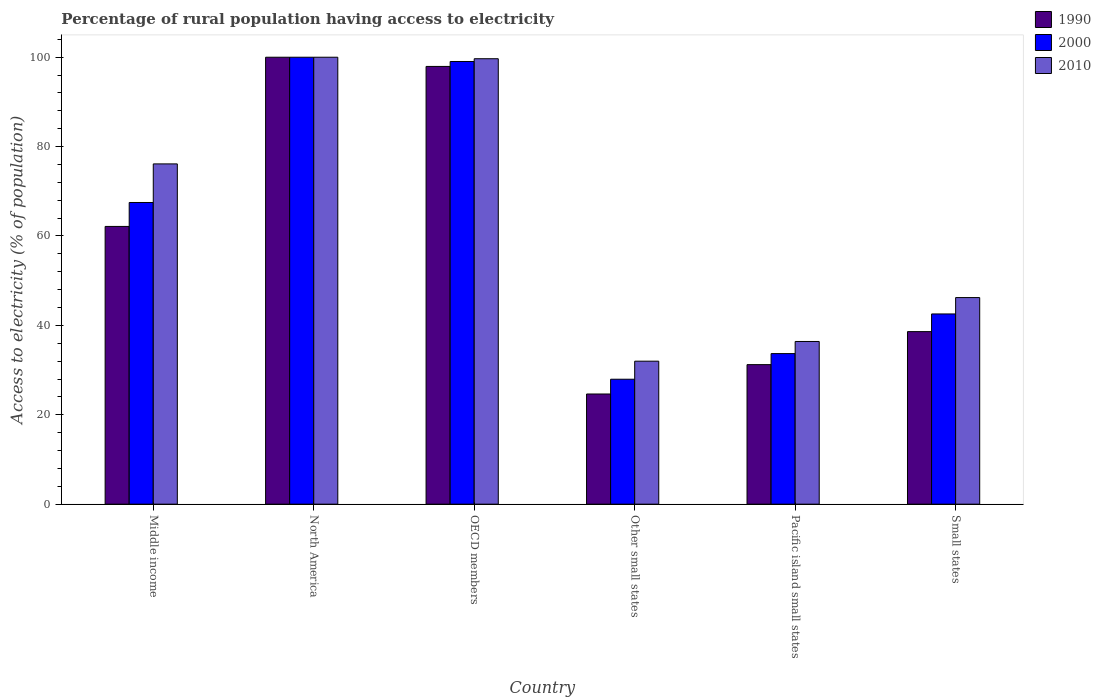How many groups of bars are there?
Offer a terse response. 6. Are the number of bars per tick equal to the number of legend labels?
Give a very brief answer. Yes. How many bars are there on the 4th tick from the left?
Your response must be concise. 3. How many bars are there on the 6th tick from the right?
Your response must be concise. 3. What is the percentage of rural population having access to electricity in 2010 in Pacific island small states?
Your answer should be compact. 36.4. Across all countries, what is the minimum percentage of rural population having access to electricity in 1990?
Give a very brief answer. 24.65. In which country was the percentage of rural population having access to electricity in 2010 minimum?
Give a very brief answer. Other small states. What is the total percentage of rural population having access to electricity in 2000 in the graph?
Give a very brief answer. 370.74. What is the difference between the percentage of rural population having access to electricity in 2010 in Middle income and that in North America?
Provide a succinct answer. -23.87. What is the difference between the percentage of rural population having access to electricity in 2000 in Middle income and the percentage of rural population having access to electricity in 2010 in OECD members?
Give a very brief answer. -32.17. What is the average percentage of rural population having access to electricity in 2000 per country?
Your response must be concise. 61.79. What is the difference between the percentage of rural population having access to electricity of/in 1990 and percentage of rural population having access to electricity of/in 2010 in Small states?
Offer a terse response. -7.62. What is the ratio of the percentage of rural population having access to electricity in 1990 in Other small states to that in Pacific island small states?
Provide a succinct answer. 0.79. What is the difference between the highest and the second highest percentage of rural population having access to electricity in 2000?
Your response must be concise. -31.55. What is the difference between the highest and the lowest percentage of rural population having access to electricity in 2000?
Give a very brief answer. 72.04. In how many countries, is the percentage of rural population having access to electricity in 2010 greater than the average percentage of rural population having access to electricity in 2010 taken over all countries?
Your answer should be compact. 3. What does the 1st bar from the left in OECD members represents?
Make the answer very short. 1990. How many bars are there?
Offer a very short reply. 18. Are the values on the major ticks of Y-axis written in scientific E-notation?
Your response must be concise. No. Where does the legend appear in the graph?
Offer a very short reply. Top right. How many legend labels are there?
Offer a terse response. 3. How are the legend labels stacked?
Offer a terse response. Vertical. What is the title of the graph?
Ensure brevity in your answer.  Percentage of rural population having access to electricity. What is the label or title of the Y-axis?
Make the answer very short. Access to electricity (% of population). What is the Access to electricity (% of population) in 1990 in Middle income?
Your answer should be compact. 62.14. What is the Access to electricity (% of population) of 2000 in Middle income?
Offer a terse response. 67.5. What is the Access to electricity (% of population) in 2010 in Middle income?
Your answer should be compact. 76.13. What is the Access to electricity (% of population) in 1990 in North America?
Provide a short and direct response. 100. What is the Access to electricity (% of population) of 2000 in North America?
Offer a very short reply. 100. What is the Access to electricity (% of population) of 2010 in North America?
Your answer should be compact. 100. What is the Access to electricity (% of population) in 1990 in OECD members?
Your answer should be very brief. 97.94. What is the Access to electricity (% of population) of 2000 in OECD members?
Keep it short and to the point. 99.04. What is the Access to electricity (% of population) of 2010 in OECD members?
Offer a terse response. 99.66. What is the Access to electricity (% of population) in 1990 in Other small states?
Provide a succinct answer. 24.65. What is the Access to electricity (% of population) in 2000 in Other small states?
Ensure brevity in your answer.  27.96. What is the Access to electricity (% of population) of 2010 in Other small states?
Give a very brief answer. 31.99. What is the Access to electricity (% of population) of 1990 in Pacific island small states?
Your answer should be compact. 31.22. What is the Access to electricity (% of population) in 2000 in Pacific island small states?
Give a very brief answer. 33.69. What is the Access to electricity (% of population) in 2010 in Pacific island small states?
Your response must be concise. 36.4. What is the Access to electricity (% of population) in 1990 in Small states?
Ensure brevity in your answer.  38.61. What is the Access to electricity (% of population) in 2000 in Small states?
Offer a terse response. 42.56. What is the Access to electricity (% of population) in 2010 in Small states?
Your response must be concise. 46.22. Across all countries, what is the maximum Access to electricity (% of population) in 2010?
Offer a terse response. 100. Across all countries, what is the minimum Access to electricity (% of population) of 1990?
Make the answer very short. 24.65. Across all countries, what is the minimum Access to electricity (% of population) in 2000?
Provide a short and direct response. 27.96. Across all countries, what is the minimum Access to electricity (% of population) in 2010?
Keep it short and to the point. 31.99. What is the total Access to electricity (% of population) in 1990 in the graph?
Make the answer very short. 354.56. What is the total Access to electricity (% of population) of 2000 in the graph?
Offer a terse response. 370.74. What is the total Access to electricity (% of population) in 2010 in the graph?
Make the answer very short. 390.41. What is the difference between the Access to electricity (% of population) in 1990 in Middle income and that in North America?
Provide a short and direct response. -37.86. What is the difference between the Access to electricity (% of population) in 2000 in Middle income and that in North America?
Your answer should be compact. -32.5. What is the difference between the Access to electricity (% of population) of 2010 in Middle income and that in North America?
Give a very brief answer. -23.87. What is the difference between the Access to electricity (% of population) in 1990 in Middle income and that in OECD members?
Provide a short and direct response. -35.8. What is the difference between the Access to electricity (% of population) of 2000 in Middle income and that in OECD members?
Your response must be concise. -31.55. What is the difference between the Access to electricity (% of population) in 2010 in Middle income and that in OECD members?
Your answer should be compact. -23.53. What is the difference between the Access to electricity (% of population) in 1990 in Middle income and that in Other small states?
Your answer should be compact. 37.49. What is the difference between the Access to electricity (% of population) of 2000 in Middle income and that in Other small states?
Provide a succinct answer. 39.54. What is the difference between the Access to electricity (% of population) of 2010 in Middle income and that in Other small states?
Make the answer very short. 44.14. What is the difference between the Access to electricity (% of population) of 1990 in Middle income and that in Pacific island small states?
Give a very brief answer. 30.92. What is the difference between the Access to electricity (% of population) in 2000 in Middle income and that in Pacific island small states?
Your answer should be compact. 33.81. What is the difference between the Access to electricity (% of population) in 2010 in Middle income and that in Pacific island small states?
Offer a very short reply. 39.73. What is the difference between the Access to electricity (% of population) of 1990 in Middle income and that in Small states?
Your answer should be very brief. 23.53. What is the difference between the Access to electricity (% of population) in 2000 in Middle income and that in Small states?
Provide a short and direct response. 24.94. What is the difference between the Access to electricity (% of population) of 2010 in Middle income and that in Small states?
Provide a succinct answer. 29.91. What is the difference between the Access to electricity (% of population) of 1990 in North America and that in OECD members?
Offer a very short reply. 2.06. What is the difference between the Access to electricity (% of population) of 2000 in North America and that in OECD members?
Make the answer very short. 0.96. What is the difference between the Access to electricity (% of population) of 2010 in North America and that in OECD members?
Make the answer very short. 0.34. What is the difference between the Access to electricity (% of population) in 1990 in North America and that in Other small states?
Your answer should be compact. 75.35. What is the difference between the Access to electricity (% of population) of 2000 in North America and that in Other small states?
Provide a succinct answer. 72.04. What is the difference between the Access to electricity (% of population) of 2010 in North America and that in Other small states?
Make the answer very short. 68.01. What is the difference between the Access to electricity (% of population) of 1990 in North America and that in Pacific island small states?
Offer a terse response. 68.78. What is the difference between the Access to electricity (% of population) of 2000 in North America and that in Pacific island small states?
Provide a succinct answer. 66.31. What is the difference between the Access to electricity (% of population) of 2010 in North America and that in Pacific island small states?
Provide a succinct answer. 63.6. What is the difference between the Access to electricity (% of population) of 1990 in North America and that in Small states?
Make the answer very short. 61.39. What is the difference between the Access to electricity (% of population) of 2000 in North America and that in Small states?
Provide a succinct answer. 57.44. What is the difference between the Access to electricity (% of population) of 2010 in North America and that in Small states?
Offer a very short reply. 53.78. What is the difference between the Access to electricity (% of population) in 1990 in OECD members and that in Other small states?
Provide a succinct answer. 73.29. What is the difference between the Access to electricity (% of population) in 2000 in OECD members and that in Other small states?
Your answer should be compact. 71.09. What is the difference between the Access to electricity (% of population) of 2010 in OECD members and that in Other small states?
Offer a terse response. 67.67. What is the difference between the Access to electricity (% of population) in 1990 in OECD members and that in Pacific island small states?
Provide a short and direct response. 66.72. What is the difference between the Access to electricity (% of population) in 2000 in OECD members and that in Pacific island small states?
Ensure brevity in your answer.  65.36. What is the difference between the Access to electricity (% of population) in 2010 in OECD members and that in Pacific island small states?
Offer a very short reply. 63.26. What is the difference between the Access to electricity (% of population) in 1990 in OECD members and that in Small states?
Keep it short and to the point. 59.33. What is the difference between the Access to electricity (% of population) of 2000 in OECD members and that in Small states?
Your response must be concise. 56.48. What is the difference between the Access to electricity (% of population) of 2010 in OECD members and that in Small states?
Provide a short and direct response. 53.44. What is the difference between the Access to electricity (% of population) in 1990 in Other small states and that in Pacific island small states?
Your answer should be compact. -6.57. What is the difference between the Access to electricity (% of population) of 2000 in Other small states and that in Pacific island small states?
Offer a terse response. -5.73. What is the difference between the Access to electricity (% of population) in 2010 in Other small states and that in Pacific island small states?
Provide a succinct answer. -4.41. What is the difference between the Access to electricity (% of population) in 1990 in Other small states and that in Small states?
Your answer should be compact. -13.96. What is the difference between the Access to electricity (% of population) of 2000 in Other small states and that in Small states?
Give a very brief answer. -14.61. What is the difference between the Access to electricity (% of population) of 2010 in Other small states and that in Small states?
Your answer should be compact. -14.23. What is the difference between the Access to electricity (% of population) of 1990 in Pacific island small states and that in Small states?
Your answer should be compact. -7.39. What is the difference between the Access to electricity (% of population) of 2000 in Pacific island small states and that in Small states?
Your response must be concise. -8.87. What is the difference between the Access to electricity (% of population) in 2010 in Pacific island small states and that in Small states?
Ensure brevity in your answer.  -9.82. What is the difference between the Access to electricity (% of population) of 1990 in Middle income and the Access to electricity (% of population) of 2000 in North America?
Provide a succinct answer. -37.86. What is the difference between the Access to electricity (% of population) in 1990 in Middle income and the Access to electricity (% of population) in 2010 in North America?
Your response must be concise. -37.86. What is the difference between the Access to electricity (% of population) of 2000 in Middle income and the Access to electricity (% of population) of 2010 in North America?
Make the answer very short. -32.5. What is the difference between the Access to electricity (% of population) of 1990 in Middle income and the Access to electricity (% of population) of 2000 in OECD members?
Provide a short and direct response. -36.9. What is the difference between the Access to electricity (% of population) in 1990 in Middle income and the Access to electricity (% of population) in 2010 in OECD members?
Your answer should be very brief. -37.52. What is the difference between the Access to electricity (% of population) in 2000 in Middle income and the Access to electricity (% of population) in 2010 in OECD members?
Your answer should be very brief. -32.17. What is the difference between the Access to electricity (% of population) in 1990 in Middle income and the Access to electricity (% of population) in 2000 in Other small states?
Provide a short and direct response. 34.19. What is the difference between the Access to electricity (% of population) in 1990 in Middle income and the Access to electricity (% of population) in 2010 in Other small states?
Offer a very short reply. 30.15. What is the difference between the Access to electricity (% of population) in 2000 in Middle income and the Access to electricity (% of population) in 2010 in Other small states?
Your answer should be very brief. 35.51. What is the difference between the Access to electricity (% of population) in 1990 in Middle income and the Access to electricity (% of population) in 2000 in Pacific island small states?
Keep it short and to the point. 28.45. What is the difference between the Access to electricity (% of population) in 1990 in Middle income and the Access to electricity (% of population) in 2010 in Pacific island small states?
Your response must be concise. 25.74. What is the difference between the Access to electricity (% of population) of 2000 in Middle income and the Access to electricity (% of population) of 2010 in Pacific island small states?
Offer a very short reply. 31.1. What is the difference between the Access to electricity (% of population) of 1990 in Middle income and the Access to electricity (% of population) of 2000 in Small states?
Ensure brevity in your answer.  19.58. What is the difference between the Access to electricity (% of population) of 1990 in Middle income and the Access to electricity (% of population) of 2010 in Small states?
Offer a very short reply. 15.92. What is the difference between the Access to electricity (% of population) in 2000 in Middle income and the Access to electricity (% of population) in 2010 in Small states?
Your answer should be compact. 21.27. What is the difference between the Access to electricity (% of population) in 1990 in North America and the Access to electricity (% of population) in 2000 in OECD members?
Your answer should be compact. 0.96. What is the difference between the Access to electricity (% of population) in 1990 in North America and the Access to electricity (% of population) in 2010 in OECD members?
Keep it short and to the point. 0.34. What is the difference between the Access to electricity (% of population) in 2000 in North America and the Access to electricity (% of population) in 2010 in OECD members?
Your response must be concise. 0.34. What is the difference between the Access to electricity (% of population) of 1990 in North America and the Access to electricity (% of population) of 2000 in Other small states?
Provide a succinct answer. 72.04. What is the difference between the Access to electricity (% of population) in 1990 in North America and the Access to electricity (% of population) in 2010 in Other small states?
Ensure brevity in your answer.  68.01. What is the difference between the Access to electricity (% of population) in 2000 in North America and the Access to electricity (% of population) in 2010 in Other small states?
Keep it short and to the point. 68.01. What is the difference between the Access to electricity (% of population) of 1990 in North America and the Access to electricity (% of population) of 2000 in Pacific island small states?
Your response must be concise. 66.31. What is the difference between the Access to electricity (% of population) of 1990 in North America and the Access to electricity (% of population) of 2010 in Pacific island small states?
Offer a terse response. 63.6. What is the difference between the Access to electricity (% of population) in 2000 in North America and the Access to electricity (% of population) in 2010 in Pacific island small states?
Your answer should be very brief. 63.6. What is the difference between the Access to electricity (% of population) in 1990 in North America and the Access to electricity (% of population) in 2000 in Small states?
Make the answer very short. 57.44. What is the difference between the Access to electricity (% of population) in 1990 in North America and the Access to electricity (% of population) in 2010 in Small states?
Keep it short and to the point. 53.78. What is the difference between the Access to electricity (% of population) of 2000 in North America and the Access to electricity (% of population) of 2010 in Small states?
Provide a short and direct response. 53.78. What is the difference between the Access to electricity (% of population) of 1990 in OECD members and the Access to electricity (% of population) of 2000 in Other small states?
Keep it short and to the point. 69.98. What is the difference between the Access to electricity (% of population) in 1990 in OECD members and the Access to electricity (% of population) in 2010 in Other small states?
Provide a short and direct response. 65.95. What is the difference between the Access to electricity (% of population) in 2000 in OECD members and the Access to electricity (% of population) in 2010 in Other small states?
Provide a succinct answer. 67.05. What is the difference between the Access to electricity (% of population) of 1990 in OECD members and the Access to electricity (% of population) of 2000 in Pacific island small states?
Provide a succinct answer. 64.25. What is the difference between the Access to electricity (% of population) in 1990 in OECD members and the Access to electricity (% of population) in 2010 in Pacific island small states?
Your answer should be very brief. 61.54. What is the difference between the Access to electricity (% of population) of 2000 in OECD members and the Access to electricity (% of population) of 2010 in Pacific island small states?
Your response must be concise. 62.64. What is the difference between the Access to electricity (% of population) of 1990 in OECD members and the Access to electricity (% of population) of 2000 in Small states?
Give a very brief answer. 55.38. What is the difference between the Access to electricity (% of population) in 1990 in OECD members and the Access to electricity (% of population) in 2010 in Small states?
Your response must be concise. 51.72. What is the difference between the Access to electricity (% of population) in 2000 in OECD members and the Access to electricity (% of population) in 2010 in Small states?
Your answer should be compact. 52.82. What is the difference between the Access to electricity (% of population) in 1990 in Other small states and the Access to electricity (% of population) in 2000 in Pacific island small states?
Your answer should be compact. -9.04. What is the difference between the Access to electricity (% of population) in 1990 in Other small states and the Access to electricity (% of population) in 2010 in Pacific island small states?
Make the answer very short. -11.75. What is the difference between the Access to electricity (% of population) in 2000 in Other small states and the Access to electricity (% of population) in 2010 in Pacific island small states?
Offer a very short reply. -8.45. What is the difference between the Access to electricity (% of population) in 1990 in Other small states and the Access to electricity (% of population) in 2000 in Small states?
Offer a terse response. -17.91. What is the difference between the Access to electricity (% of population) of 1990 in Other small states and the Access to electricity (% of population) of 2010 in Small states?
Your answer should be very brief. -21.57. What is the difference between the Access to electricity (% of population) in 2000 in Other small states and the Access to electricity (% of population) in 2010 in Small states?
Your response must be concise. -18.27. What is the difference between the Access to electricity (% of population) in 1990 in Pacific island small states and the Access to electricity (% of population) in 2000 in Small states?
Give a very brief answer. -11.34. What is the difference between the Access to electricity (% of population) in 1990 in Pacific island small states and the Access to electricity (% of population) in 2010 in Small states?
Your answer should be very brief. -15.01. What is the difference between the Access to electricity (% of population) in 2000 in Pacific island small states and the Access to electricity (% of population) in 2010 in Small states?
Give a very brief answer. -12.54. What is the average Access to electricity (% of population) of 1990 per country?
Your answer should be very brief. 59.09. What is the average Access to electricity (% of population) in 2000 per country?
Your answer should be very brief. 61.79. What is the average Access to electricity (% of population) in 2010 per country?
Your answer should be compact. 65.07. What is the difference between the Access to electricity (% of population) in 1990 and Access to electricity (% of population) in 2000 in Middle income?
Your response must be concise. -5.36. What is the difference between the Access to electricity (% of population) in 1990 and Access to electricity (% of population) in 2010 in Middle income?
Give a very brief answer. -13.99. What is the difference between the Access to electricity (% of population) of 2000 and Access to electricity (% of population) of 2010 in Middle income?
Provide a short and direct response. -8.63. What is the difference between the Access to electricity (% of population) in 1990 and Access to electricity (% of population) in 2010 in North America?
Ensure brevity in your answer.  0. What is the difference between the Access to electricity (% of population) in 2000 and Access to electricity (% of population) in 2010 in North America?
Provide a succinct answer. 0. What is the difference between the Access to electricity (% of population) of 1990 and Access to electricity (% of population) of 2000 in OECD members?
Keep it short and to the point. -1.1. What is the difference between the Access to electricity (% of population) of 1990 and Access to electricity (% of population) of 2010 in OECD members?
Offer a very short reply. -1.72. What is the difference between the Access to electricity (% of population) of 2000 and Access to electricity (% of population) of 2010 in OECD members?
Provide a short and direct response. -0.62. What is the difference between the Access to electricity (% of population) in 1990 and Access to electricity (% of population) in 2000 in Other small states?
Ensure brevity in your answer.  -3.31. What is the difference between the Access to electricity (% of population) in 1990 and Access to electricity (% of population) in 2010 in Other small states?
Give a very brief answer. -7.34. What is the difference between the Access to electricity (% of population) in 2000 and Access to electricity (% of population) in 2010 in Other small states?
Offer a terse response. -4.04. What is the difference between the Access to electricity (% of population) of 1990 and Access to electricity (% of population) of 2000 in Pacific island small states?
Offer a very short reply. -2.47. What is the difference between the Access to electricity (% of population) of 1990 and Access to electricity (% of population) of 2010 in Pacific island small states?
Your answer should be compact. -5.18. What is the difference between the Access to electricity (% of population) in 2000 and Access to electricity (% of population) in 2010 in Pacific island small states?
Provide a short and direct response. -2.71. What is the difference between the Access to electricity (% of population) of 1990 and Access to electricity (% of population) of 2000 in Small states?
Provide a succinct answer. -3.95. What is the difference between the Access to electricity (% of population) in 1990 and Access to electricity (% of population) in 2010 in Small states?
Ensure brevity in your answer.  -7.62. What is the difference between the Access to electricity (% of population) of 2000 and Access to electricity (% of population) of 2010 in Small states?
Give a very brief answer. -3.66. What is the ratio of the Access to electricity (% of population) in 1990 in Middle income to that in North America?
Your answer should be very brief. 0.62. What is the ratio of the Access to electricity (% of population) of 2000 in Middle income to that in North America?
Your answer should be very brief. 0.68. What is the ratio of the Access to electricity (% of population) in 2010 in Middle income to that in North America?
Your response must be concise. 0.76. What is the ratio of the Access to electricity (% of population) in 1990 in Middle income to that in OECD members?
Offer a terse response. 0.63. What is the ratio of the Access to electricity (% of population) in 2000 in Middle income to that in OECD members?
Your response must be concise. 0.68. What is the ratio of the Access to electricity (% of population) of 2010 in Middle income to that in OECD members?
Keep it short and to the point. 0.76. What is the ratio of the Access to electricity (% of population) of 1990 in Middle income to that in Other small states?
Your response must be concise. 2.52. What is the ratio of the Access to electricity (% of population) of 2000 in Middle income to that in Other small states?
Make the answer very short. 2.41. What is the ratio of the Access to electricity (% of population) in 2010 in Middle income to that in Other small states?
Offer a terse response. 2.38. What is the ratio of the Access to electricity (% of population) in 1990 in Middle income to that in Pacific island small states?
Provide a short and direct response. 1.99. What is the ratio of the Access to electricity (% of population) of 2000 in Middle income to that in Pacific island small states?
Your answer should be very brief. 2. What is the ratio of the Access to electricity (% of population) in 2010 in Middle income to that in Pacific island small states?
Offer a very short reply. 2.09. What is the ratio of the Access to electricity (% of population) of 1990 in Middle income to that in Small states?
Offer a very short reply. 1.61. What is the ratio of the Access to electricity (% of population) in 2000 in Middle income to that in Small states?
Make the answer very short. 1.59. What is the ratio of the Access to electricity (% of population) of 2010 in Middle income to that in Small states?
Your answer should be compact. 1.65. What is the ratio of the Access to electricity (% of population) in 2000 in North America to that in OECD members?
Make the answer very short. 1.01. What is the ratio of the Access to electricity (% of population) in 1990 in North America to that in Other small states?
Keep it short and to the point. 4.06. What is the ratio of the Access to electricity (% of population) of 2000 in North America to that in Other small states?
Offer a very short reply. 3.58. What is the ratio of the Access to electricity (% of population) in 2010 in North America to that in Other small states?
Provide a short and direct response. 3.13. What is the ratio of the Access to electricity (% of population) of 1990 in North America to that in Pacific island small states?
Offer a terse response. 3.2. What is the ratio of the Access to electricity (% of population) of 2000 in North America to that in Pacific island small states?
Your response must be concise. 2.97. What is the ratio of the Access to electricity (% of population) in 2010 in North America to that in Pacific island small states?
Offer a terse response. 2.75. What is the ratio of the Access to electricity (% of population) of 1990 in North America to that in Small states?
Provide a short and direct response. 2.59. What is the ratio of the Access to electricity (% of population) of 2000 in North America to that in Small states?
Provide a succinct answer. 2.35. What is the ratio of the Access to electricity (% of population) in 2010 in North America to that in Small states?
Provide a succinct answer. 2.16. What is the ratio of the Access to electricity (% of population) in 1990 in OECD members to that in Other small states?
Keep it short and to the point. 3.97. What is the ratio of the Access to electricity (% of population) of 2000 in OECD members to that in Other small states?
Make the answer very short. 3.54. What is the ratio of the Access to electricity (% of population) in 2010 in OECD members to that in Other small states?
Give a very brief answer. 3.12. What is the ratio of the Access to electricity (% of population) of 1990 in OECD members to that in Pacific island small states?
Offer a terse response. 3.14. What is the ratio of the Access to electricity (% of population) in 2000 in OECD members to that in Pacific island small states?
Provide a short and direct response. 2.94. What is the ratio of the Access to electricity (% of population) of 2010 in OECD members to that in Pacific island small states?
Provide a short and direct response. 2.74. What is the ratio of the Access to electricity (% of population) of 1990 in OECD members to that in Small states?
Ensure brevity in your answer.  2.54. What is the ratio of the Access to electricity (% of population) in 2000 in OECD members to that in Small states?
Your answer should be compact. 2.33. What is the ratio of the Access to electricity (% of population) in 2010 in OECD members to that in Small states?
Provide a short and direct response. 2.16. What is the ratio of the Access to electricity (% of population) in 1990 in Other small states to that in Pacific island small states?
Make the answer very short. 0.79. What is the ratio of the Access to electricity (% of population) of 2000 in Other small states to that in Pacific island small states?
Keep it short and to the point. 0.83. What is the ratio of the Access to electricity (% of population) of 2010 in Other small states to that in Pacific island small states?
Offer a terse response. 0.88. What is the ratio of the Access to electricity (% of population) in 1990 in Other small states to that in Small states?
Offer a terse response. 0.64. What is the ratio of the Access to electricity (% of population) of 2000 in Other small states to that in Small states?
Ensure brevity in your answer.  0.66. What is the ratio of the Access to electricity (% of population) in 2010 in Other small states to that in Small states?
Provide a succinct answer. 0.69. What is the ratio of the Access to electricity (% of population) of 1990 in Pacific island small states to that in Small states?
Offer a terse response. 0.81. What is the ratio of the Access to electricity (% of population) of 2000 in Pacific island small states to that in Small states?
Provide a succinct answer. 0.79. What is the ratio of the Access to electricity (% of population) in 2010 in Pacific island small states to that in Small states?
Your answer should be compact. 0.79. What is the difference between the highest and the second highest Access to electricity (% of population) of 1990?
Provide a short and direct response. 2.06. What is the difference between the highest and the second highest Access to electricity (% of population) in 2000?
Offer a terse response. 0.96. What is the difference between the highest and the second highest Access to electricity (% of population) of 2010?
Give a very brief answer. 0.34. What is the difference between the highest and the lowest Access to electricity (% of population) in 1990?
Your answer should be compact. 75.35. What is the difference between the highest and the lowest Access to electricity (% of population) in 2000?
Your answer should be very brief. 72.04. What is the difference between the highest and the lowest Access to electricity (% of population) of 2010?
Your response must be concise. 68.01. 